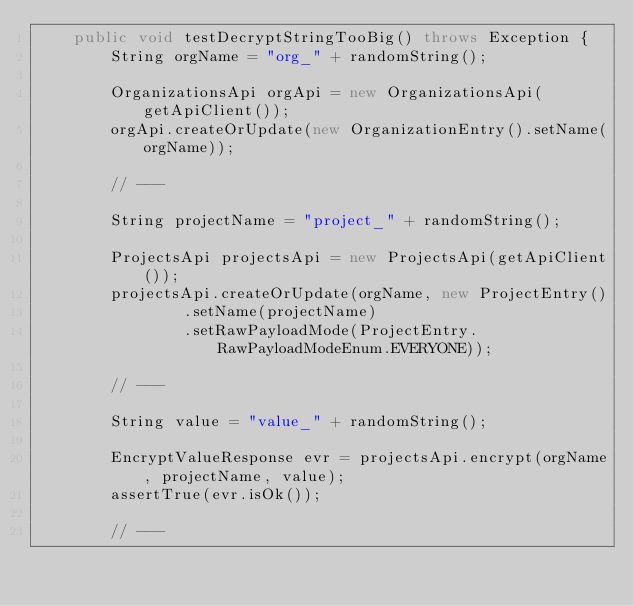Convert code to text. <code><loc_0><loc_0><loc_500><loc_500><_Java_>    public void testDecryptStringTooBig() throws Exception {
        String orgName = "org_" + randomString();

        OrganizationsApi orgApi = new OrganizationsApi(getApiClient());
        orgApi.createOrUpdate(new OrganizationEntry().setName(orgName));

        // ---

        String projectName = "project_" + randomString();

        ProjectsApi projectsApi = new ProjectsApi(getApiClient());
        projectsApi.createOrUpdate(orgName, new ProjectEntry()
                .setName(projectName)
                .setRawPayloadMode(ProjectEntry.RawPayloadModeEnum.EVERYONE));

        // ---

        String value = "value_" + randomString();

        EncryptValueResponse evr = projectsApi.encrypt(orgName, projectName, value);
        assertTrue(evr.isOk());

        // ---
</code> 